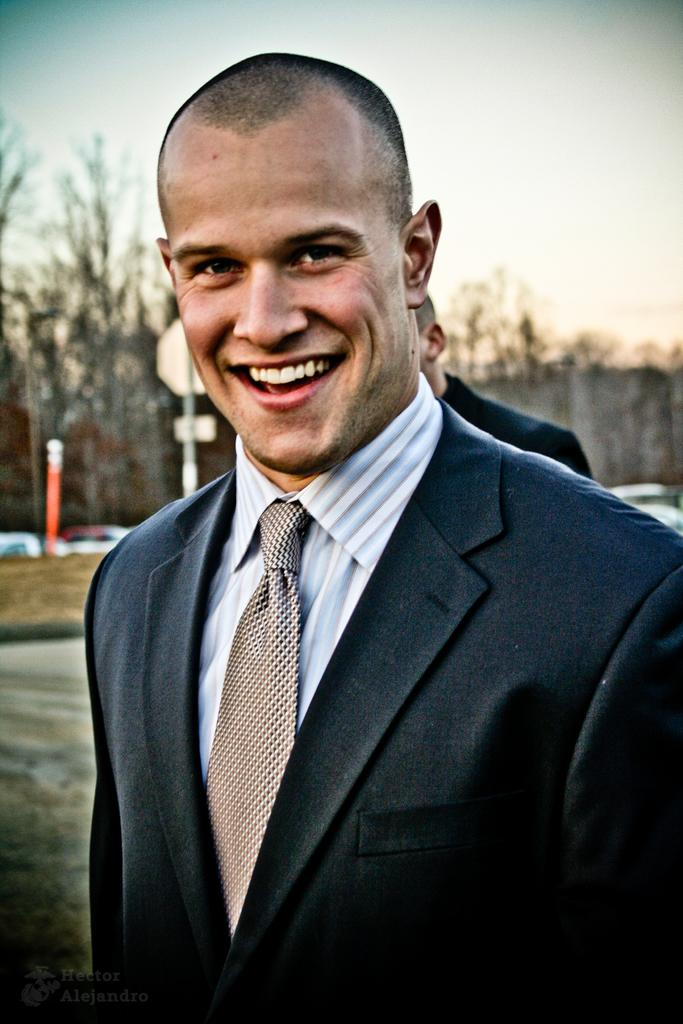What is the person in the image wearing? The person is wearing a blazer, shirt, and tie in the image. What is the person in the image doing? The person is standing and smiling. Can you describe the background of the image? There is another person, boards, trees, and the sky visible in the background. What type of cream can be seen on the person's face in the image? There is no cream visible on the person's face in the image. What level of the building is the person standing on in the image? The provided facts do not mention any information about the level of the building, so it cannot be determined from the image. 